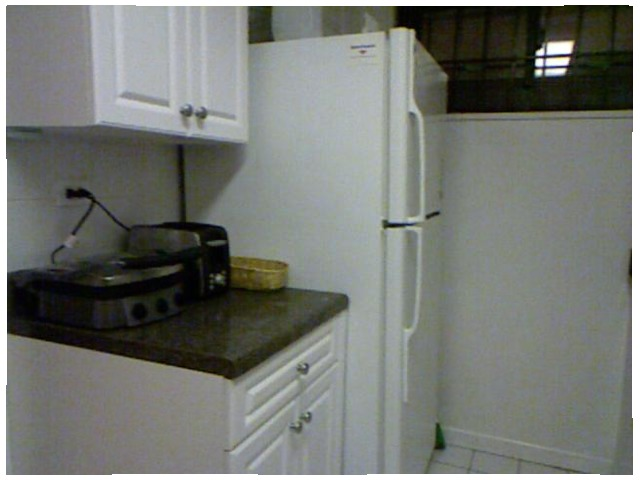<image>
Is there a refrigerator on the counter? No. The refrigerator is not positioned on the counter. They may be near each other, but the refrigerator is not supported by or resting on top of the counter. Is there a toaster to the right of the refrigerator? No. The toaster is not to the right of the refrigerator. The horizontal positioning shows a different relationship. 